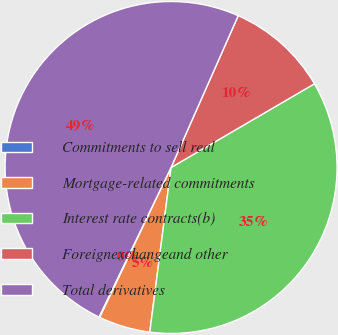Convert chart. <chart><loc_0><loc_0><loc_500><loc_500><pie_chart><fcel>Commitments to sell real<fcel>Mortgage-related commitments<fcel>Interest rate contracts(b)<fcel>Foreignexchangeand other<fcel>Total derivatives<nl><fcel>0.08%<fcel>5.02%<fcel>35.46%<fcel>9.96%<fcel>49.49%<nl></chart> 